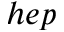Convert formula to latex. <formula><loc_0><loc_0><loc_500><loc_500>h e p</formula> 